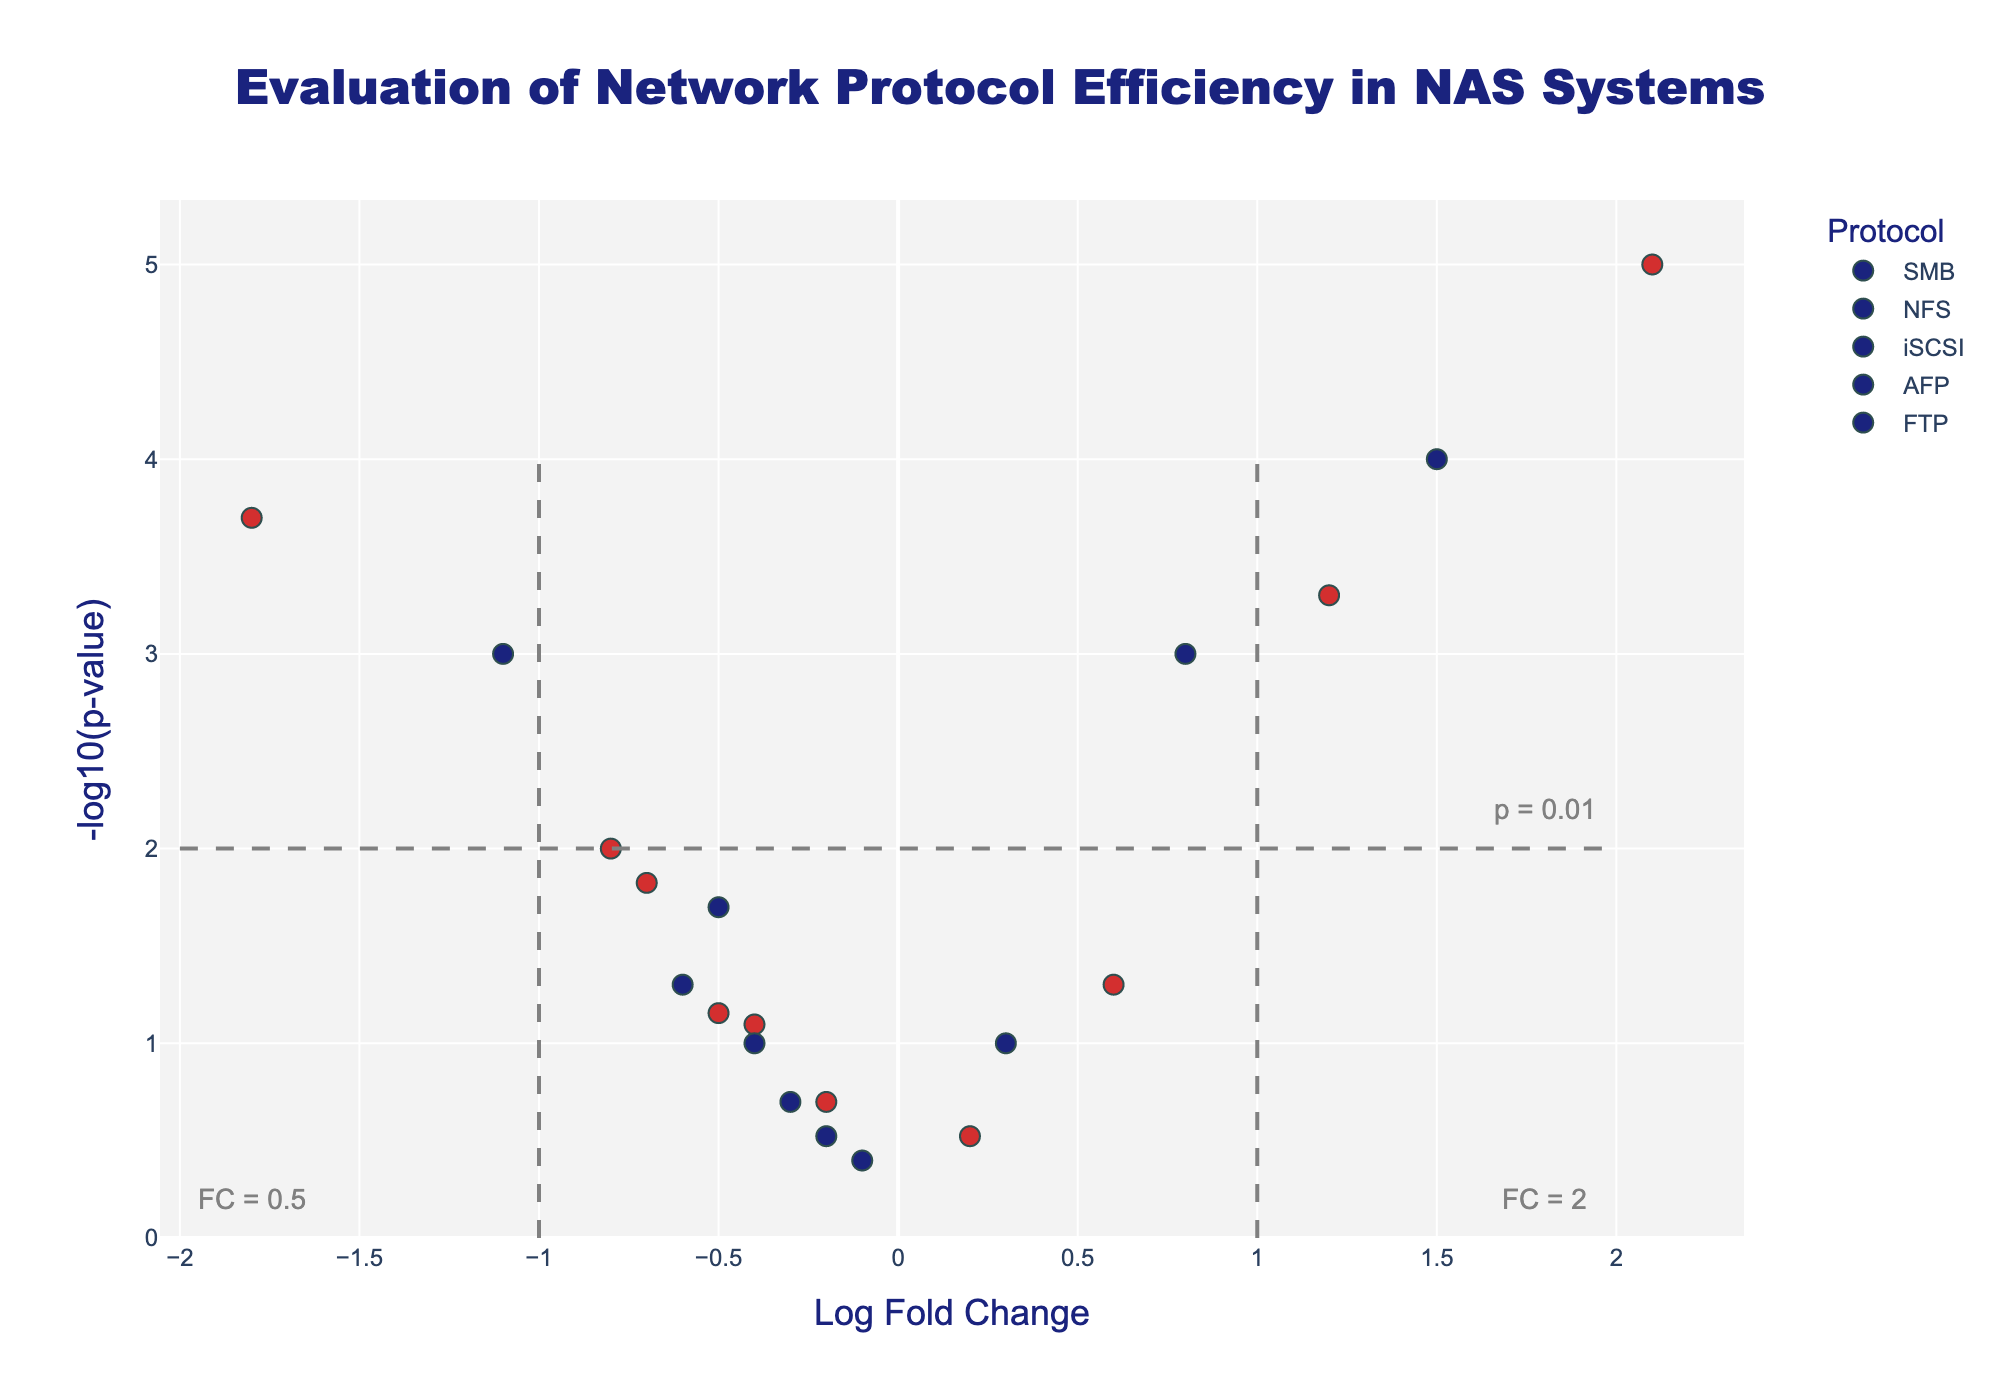How many protocols are analyzed in the figure? The figure shows different colors for each protocol, and the legend lists the names of these protocols. By counting the unique names in the legend, we can determine the number of protocols analyzed.
Answer: 5 What does a negative Log Fold Change indicate in this context? In the context of a volcano plot, a negative Log Fold Change indicates that the efficiency of the protocol is lower for that transfer type and file size combination compared to the baseline or control. This is represented by markers on the left side of the plot.
Answer: Lower efficiency Which file size has higher representation in the shaded markers? By observing the markers, note that colors represent different file sizes. The shades corresponding to '1GB' and '10GB' can differentiate how many data points each file size has. By comparing the counts visually, we can determine the answer.
Answer: 10GB Which protocol shows the highest efficiency in read transfers for 10GB files? To determine the highest efficiency, look for the largest positive Log Fold Change for the specified conditions. Filter down to the protocol with the highest Log Fold Change marker in the relevant context.
Answer: iSCSI What is the significance threshold line depicted in the plot? Significance thresholds are shown as dashed horizontal lines. These typically represent a p-value cut-off like 0.01 or 0.05. By examining the annotations and y-axis values where these lines are placed, we can identify which threshold they represent.
Answer: p-value = 0.01 Compare the efficiency of the iSCSI protocol for 1GB read and 1GB write transfers. Which transfer type is more efficient? Compare the Log Fold Change values for iSCSI in 1GB read and write transfers. The marker with a higher Log Fold Change represents the more efficient transfer type.
Answer: 1GB read For which protocol and transfer type combinations do the markers fall below the p-value threshold line of 0.01? Observe the markers below the dashed line at y = 2, indicating a p-value of 0.01. Identify the protocol and transfer type for those markers by hovering or referring to the closest annotations.
Answer: SMB (1GB Read, 10GB Read), iSCSI (1GB Read, 1GB Write, 10GB Read, 10GB Write) Which protocol has the broadest range of Log Fold Change values? To find the protocol with the broadest range, visually compare the spread of markers (leftmost to rightmost) for each protocol. The protocol with the widest horizontal range has the broadest Log Fold Change values.
Answer: iSCSI How does SMB protocol's efficiency compare between 10GB read and 10GB write transfers? Compare the markers for SMB under 10GB read and write transfers. Identify the Log Fold Change values for each and determine which is higher or lower.
Answer: 10GB read is more efficient What patterns can be seen in the efficiency of AFP protocol across different transfer types and file sizes? Look at the positioning of AFP protocol's markers for the different conditions. Note the Log Fold Change and p-value, observing whether the markers cluster in any particular regions or represent similar trends across conditions.
Answer: AFP shows mostly negative or low fold changes, indicating lower efficiency, with no markers crossing significant thresholds 